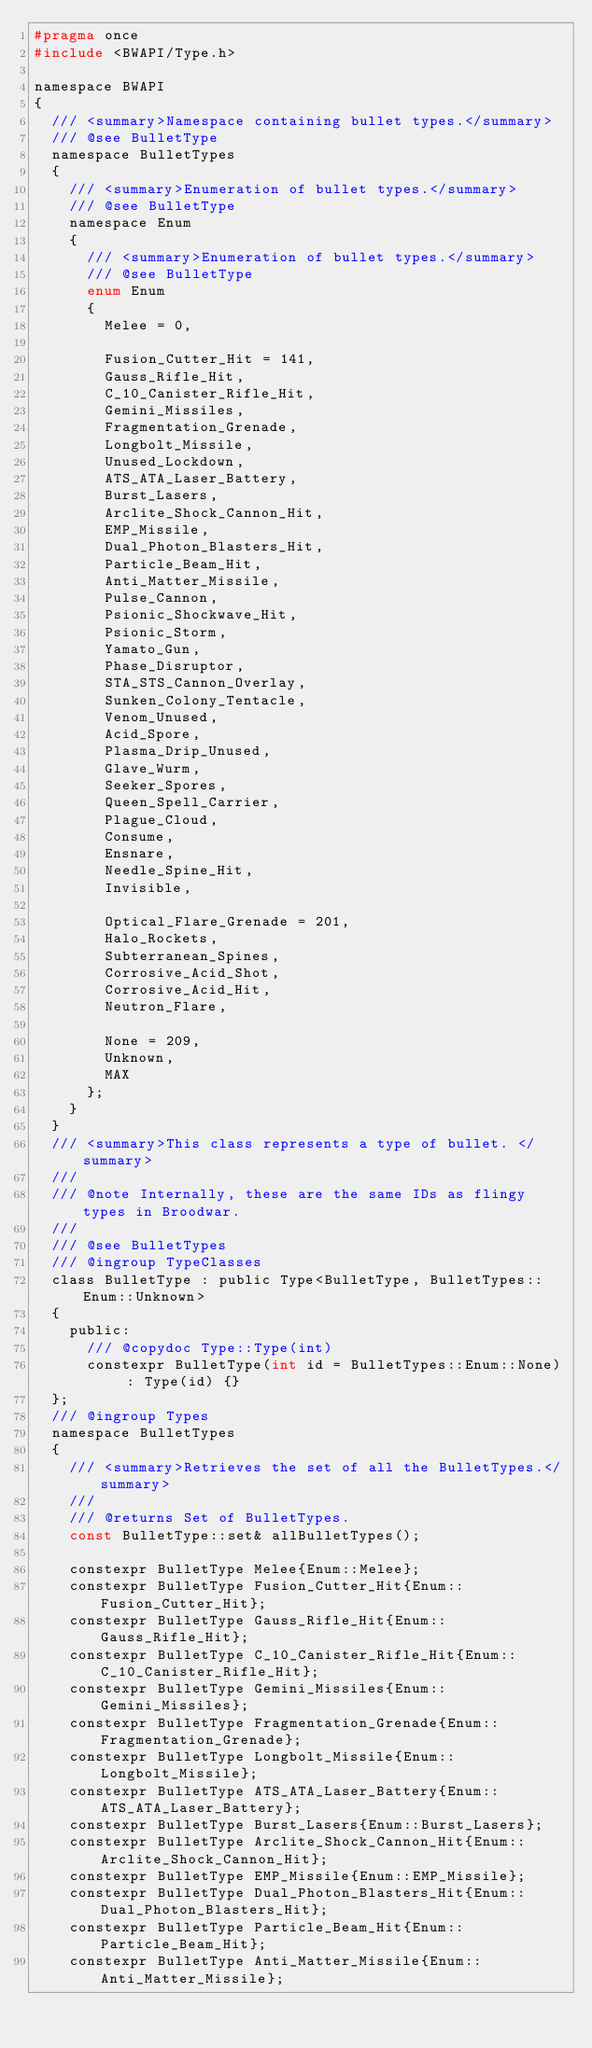<code> <loc_0><loc_0><loc_500><loc_500><_C_>#pragma once
#include <BWAPI/Type.h>

namespace BWAPI
{
  /// <summary>Namespace containing bullet types.</summary>
  /// @see BulletType
  namespace BulletTypes
  {
    /// <summary>Enumeration of bullet types.</summary>
    /// @see BulletType
    namespace Enum
    {
      /// <summary>Enumeration of bullet types.</summary>
      /// @see BulletType
      enum Enum
      {
        Melee = 0,

        Fusion_Cutter_Hit = 141,
        Gauss_Rifle_Hit,
        C_10_Canister_Rifle_Hit,
        Gemini_Missiles,
        Fragmentation_Grenade,
        Longbolt_Missile,
        Unused_Lockdown,
        ATS_ATA_Laser_Battery,
        Burst_Lasers,
        Arclite_Shock_Cannon_Hit,
        EMP_Missile,
        Dual_Photon_Blasters_Hit,
        Particle_Beam_Hit,
        Anti_Matter_Missile,
        Pulse_Cannon,
        Psionic_Shockwave_Hit,
        Psionic_Storm,
        Yamato_Gun,
        Phase_Disruptor,
        STA_STS_Cannon_Overlay,
        Sunken_Colony_Tentacle,
        Venom_Unused,
        Acid_Spore,
        Plasma_Drip_Unused,
        Glave_Wurm,
        Seeker_Spores,
        Queen_Spell_Carrier,
        Plague_Cloud,
        Consume,
        Ensnare,
        Needle_Spine_Hit,
        Invisible,

        Optical_Flare_Grenade = 201,
        Halo_Rockets,
        Subterranean_Spines,
        Corrosive_Acid_Shot,
        Corrosive_Acid_Hit,
        Neutron_Flare,

        None = 209,
        Unknown,
        MAX
      };
    }
  }
  /// <summary>This class represents a type of bullet. </summary>
  ///
  /// @note Internally, these are the same IDs as flingy types in Broodwar.
  ///
  /// @see BulletTypes
  /// @ingroup TypeClasses
  class BulletType : public Type<BulletType, BulletTypes::Enum::Unknown>
  {
    public:
      /// @copydoc Type::Type(int)
      constexpr BulletType(int id = BulletTypes::Enum::None) : Type(id) {}
  };
  /// @ingroup Types
  namespace BulletTypes
  {
    /// <summary>Retrieves the set of all the BulletTypes.</summary>
    ///
    /// @returns Set of BulletTypes.
    const BulletType::set& allBulletTypes();

    constexpr BulletType Melee{Enum::Melee};
    constexpr BulletType Fusion_Cutter_Hit{Enum::Fusion_Cutter_Hit};
    constexpr BulletType Gauss_Rifle_Hit{Enum::Gauss_Rifle_Hit};
    constexpr BulletType C_10_Canister_Rifle_Hit{Enum::C_10_Canister_Rifle_Hit};
    constexpr BulletType Gemini_Missiles{Enum::Gemini_Missiles};
    constexpr BulletType Fragmentation_Grenade{Enum::Fragmentation_Grenade};
    constexpr BulletType Longbolt_Missile{Enum::Longbolt_Missile};
    constexpr BulletType ATS_ATA_Laser_Battery{Enum::ATS_ATA_Laser_Battery};
    constexpr BulletType Burst_Lasers{Enum::Burst_Lasers};
    constexpr BulletType Arclite_Shock_Cannon_Hit{Enum::Arclite_Shock_Cannon_Hit};
    constexpr BulletType EMP_Missile{Enum::EMP_Missile};
    constexpr BulletType Dual_Photon_Blasters_Hit{Enum::Dual_Photon_Blasters_Hit};
    constexpr BulletType Particle_Beam_Hit{Enum::Particle_Beam_Hit};
    constexpr BulletType Anti_Matter_Missile{Enum::Anti_Matter_Missile};</code> 